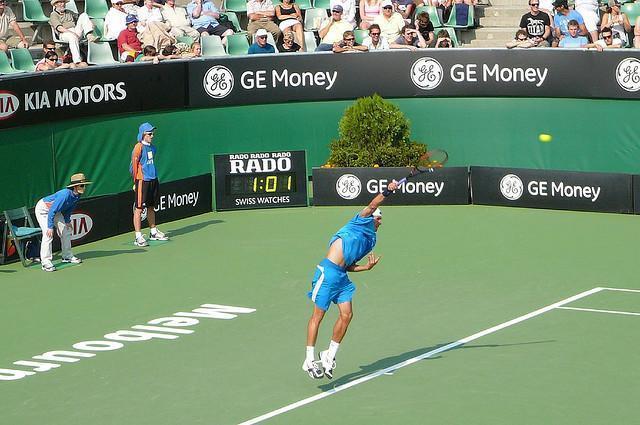How many people can you see?
Give a very brief answer. 4. 